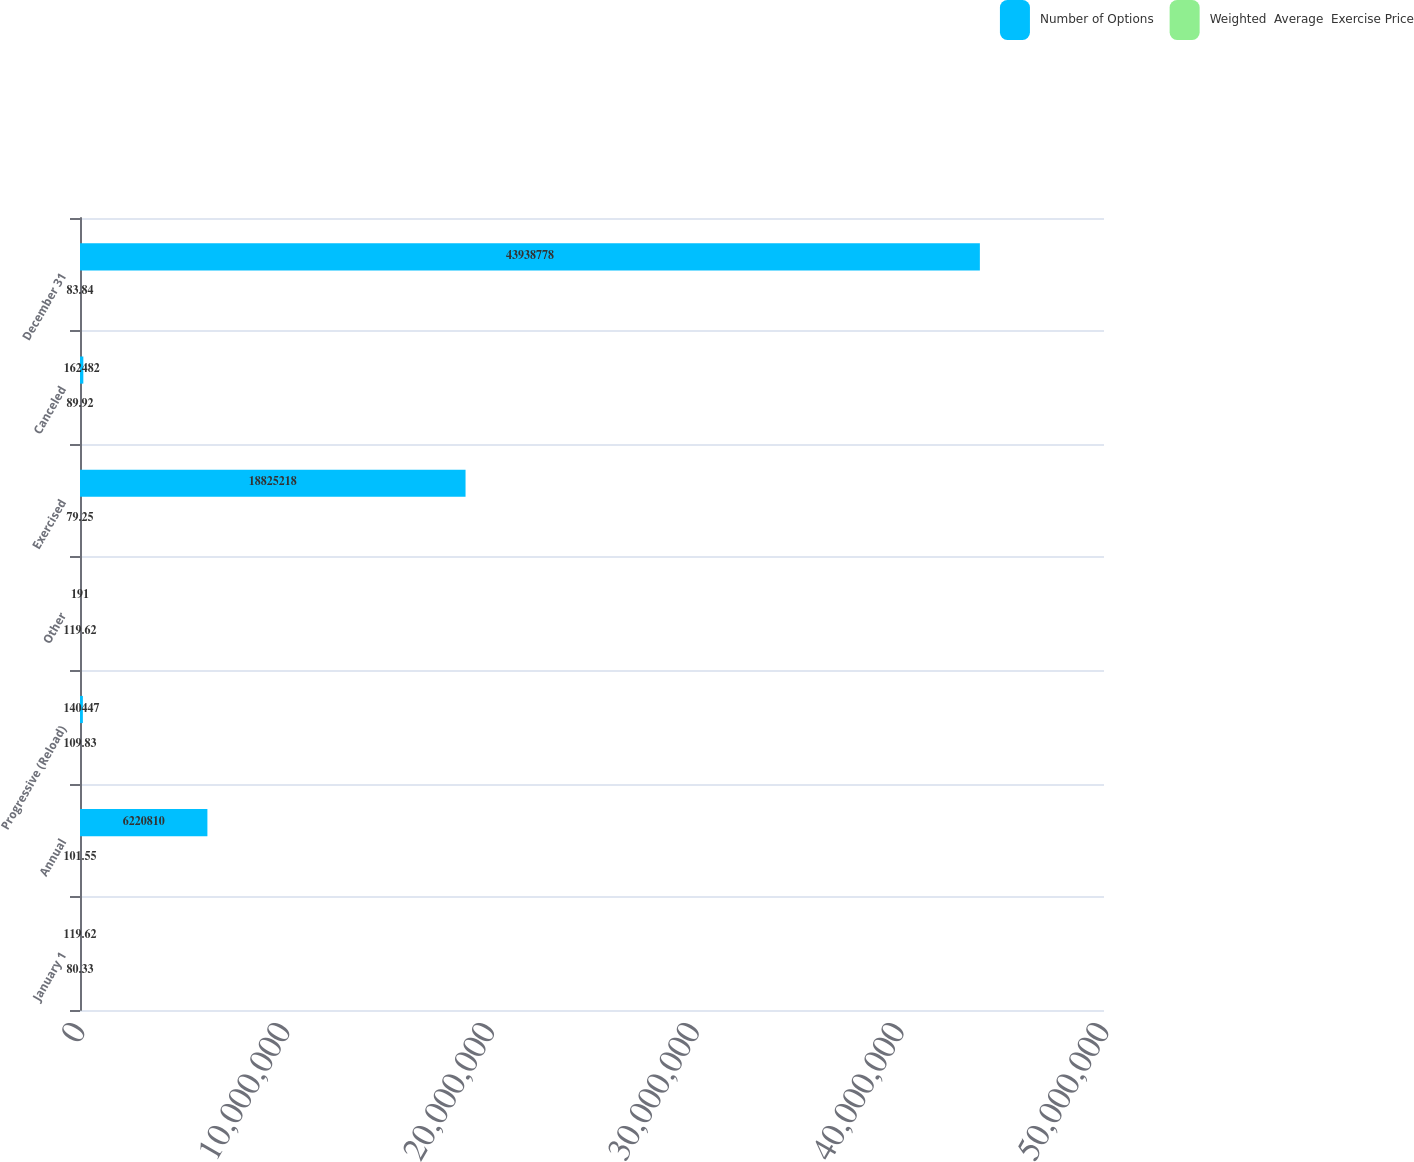Convert chart. <chart><loc_0><loc_0><loc_500><loc_500><stacked_bar_chart><ecel><fcel>January 1<fcel>Annual<fcel>Progressive (Reload)<fcel>Other<fcel>Exercised<fcel>Canceled<fcel>December 31<nl><fcel>Number of Options<fcel>119.62<fcel>6.22081e+06<fcel>140447<fcel>191<fcel>1.88252e+07<fcel>162482<fcel>4.39388e+07<nl><fcel>Weighted  Average  Exercise Price<fcel>80.33<fcel>101.55<fcel>109.83<fcel>119.62<fcel>79.25<fcel>89.92<fcel>83.84<nl></chart> 